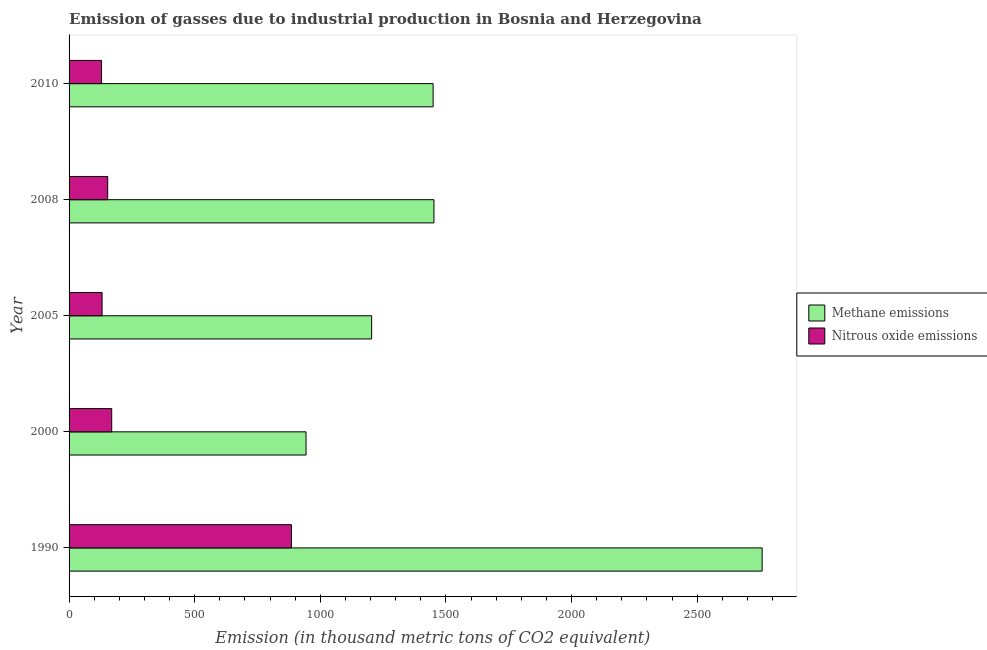How many different coloured bars are there?
Your response must be concise. 2. Are the number of bars per tick equal to the number of legend labels?
Provide a short and direct response. Yes. Are the number of bars on each tick of the Y-axis equal?
Give a very brief answer. Yes. In how many cases, is the number of bars for a given year not equal to the number of legend labels?
Provide a short and direct response. 0. What is the amount of methane emissions in 2008?
Offer a very short reply. 1452.3. Across all years, what is the maximum amount of methane emissions?
Provide a short and direct response. 2758.5. Across all years, what is the minimum amount of nitrous oxide emissions?
Your answer should be compact. 129.2. In which year was the amount of methane emissions maximum?
Your answer should be very brief. 1990. In which year was the amount of methane emissions minimum?
Give a very brief answer. 2000. What is the total amount of methane emissions in the graph?
Your answer should be very brief. 7807.3. What is the difference between the amount of methane emissions in 2005 and that in 2008?
Your answer should be compact. -248. What is the difference between the amount of nitrous oxide emissions in 2005 and the amount of methane emissions in 2008?
Keep it short and to the point. -1320.9. What is the average amount of methane emissions per year?
Make the answer very short. 1561.46. In the year 2008, what is the difference between the amount of methane emissions and amount of nitrous oxide emissions?
Ensure brevity in your answer.  1298.6. What is the ratio of the amount of nitrous oxide emissions in 2000 to that in 2005?
Your answer should be very brief. 1.29. Is the difference between the amount of methane emissions in 1990 and 2000 greater than the difference between the amount of nitrous oxide emissions in 1990 and 2000?
Make the answer very short. Yes. What is the difference between the highest and the second highest amount of methane emissions?
Your response must be concise. 1306.2. What is the difference between the highest and the lowest amount of nitrous oxide emissions?
Your answer should be very brief. 755.8. Is the sum of the amount of methane emissions in 1990 and 2010 greater than the maximum amount of nitrous oxide emissions across all years?
Your answer should be very brief. Yes. What does the 2nd bar from the top in 2008 represents?
Offer a very short reply. Methane emissions. What does the 2nd bar from the bottom in 2005 represents?
Ensure brevity in your answer.  Nitrous oxide emissions. How many bars are there?
Offer a very short reply. 10. Are all the bars in the graph horizontal?
Give a very brief answer. Yes. Does the graph contain any zero values?
Make the answer very short. No. Does the graph contain grids?
Make the answer very short. No. Where does the legend appear in the graph?
Offer a very short reply. Center right. How many legend labels are there?
Keep it short and to the point. 2. How are the legend labels stacked?
Keep it short and to the point. Vertical. What is the title of the graph?
Provide a short and direct response. Emission of gasses due to industrial production in Bosnia and Herzegovina. What is the label or title of the X-axis?
Offer a terse response. Emission (in thousand metric tons of CO2 equivalent). What is the label or title of the Y-axis?
Give a very brief answer. Year. What is the Emission (in thousand metric tons of CO2 equivalent) of Methane emissions in 1990?
Offer a terse response. 2758.5. What is the Emission (in thousand metric tons of CO2 equivalent) of Nitrous oxide emissions in 1990?
Offer a very short reply. 885. What is the Emission (in thousand metric tons of CO2 equivalent) in Methane emissions in 2000?
Give a very brief answer. 943.2. What is the Emission (in thousand metric tons of CO2 equivalent) of Nitrous oxide emissions in 2000?
Offer a very short reply. 169.7. What is the Emission (in thousand metric tons of CO2 equivalent) of Methane emissions in 2005?
Keep it short and to the point. 1204.3. What is the Emission (in thousand metric tons of CO2 equivalent) of Nitrous oxide emissions in 2005?
Make the answer very short. 131.4. What is the Emission (in thousand metric tons of CO2 equivalent) in Methane emissions in 2008?
Ensure brevity in your answer.  1452.3. What is the Emission (in thousand metric tons of CO2 equivalent) of Nitrous oxide emissions in 2008?
Offer a terse response. 153.7. What is the Emission (in thousand metric tons of CO2 equivalent) in Methane emissions in 2010?
Ensure brevity in your answer.  1449. What is the Emission (in thousand metric tons of CO2 equivalent) of Nitrous oxide emissions in 2010?
Your answer should be compact. 129.2. Across all years, what is the maximum Emission (in thousand metric tons of CO2 equivalent) of Methane emissions?
Provide a succinct answer. 2758.5. Across all years, what is the maximum Emission (in thousand metric tons of CO2 equivalent) of Nitrous oxide emissions?
Give a very brief answer. 885. Across all years, what is the minimum Emission (in thousand metric tons of CO2 equivalent) of Methane emissions?
Your answer should be compact. 943.2. Across all years, what is the minimum Emission (in thousand metric tons of CO2 equivalent) in Nitrous oxide emissions?
Your answer should be compact. 129.2. What is the total Emission (in thousand metric tons of CO2 equivalent) of Methane emissions in the graph?
Offer a terse response. 7807.3. What is the total Emission (in thousand metric tons of CO2 equivalent) in Nitrous oxide emissions in the graph?
Provide a short and direct response. 1469. What is the difference between the Emission (in thousand metric tons of CO2 equivalent) in Methane emissions in 1990 and that in 2000?
Provide a succinct answer. 1815.3. What is the difference between the Emission (in thousand metric tons of CO2 equivalent) in Nitrous oxide emissions in 1990 and that in 2000?
Keep it short and to the point. 715.3. What is the difference between the Emission (in thousand metric tons of CO2 equivalent) of Methane emissions in 1990 and that in 2005?
Offer a terse response. 1554.2. What is the difference between the Emission (in thousand metric tons of CO2 equivalent) of Nitrous oxide emissions in 1990 and that in 2005?
Keep it short and to the point. 753.6. What is the difference between the Emission (in thousand metric tons of CO2 equivalent) in Methane emissions in 1990 and that in 2008?
Offer a very short reply. 1306.2. What is the difference between the Emission (in thousand metric tons of CO2 equivalent) of Nitrous oxide emissions in 1990 and that in 2008?
Provide a succinct answer. 731.3. What is the difference between the Emission (in thousand metric tons of CO2 equivalent) of Methane emissions in 1990 and that in 2010?
Your response must be concise. 1309.5. What is the difference between the Emission (in thousand metric tons of CO2 equivalent) of Nitrous oxide emissions in 1990 and that in 2010?
Keep it short and to the point. 755.8. What is the difference between the Emission (in thousand metric tons of CO2 equivalent) of Methane emissions in 2000 and that in 2005?
Your answer should be very brief. -261.1. What is the difference between the Emission (in thousand metric tons of CO2 equivalent) of Nitrous oxide emissions in 2000 and that in 2005?
Give a very brief answer. 38.3. What is the difference between the Emission (in thousand metric tons of CO2 equivalent) in Methane emissions in 2000 and that in 2008?
Give a very brief answer. -509.1. What is the difference between the Emission (in thousand metric tons of CO2 equivalent) in Nitrous oxide emissions in 2000 and that in 2008?
Offer a very short reply. 16. What is the difference between the Emission (in thousand metric tons of CO2 equivalent) in Methane emissions in 2000 and that in 2010?
Offer a terse response. -505.8. What is the difference between the Emission (in thousand metric tons of CO2 equivalent) of Nitrous oxide emissions in 2000 and that in 2010?
Ensure brevity in your answer.  40.5. What is the difference between the Emission (in thousand metric tons of CO2 equivalent) of Methane emissions in 2005 and that in 2008?
Keep it short and to the point. -248. What is the difference between the Emission (in thousand metric tons of CO2 equivalent) of Nitrous oxide emissions in 2005 and that in 2008?
Make the answer very short. -22.3. What is the difference between the Emission (in thousand metric tons of CO2 equivalent) in Methane emissions in 2005 and that in 2010?
Give a very brief answer. -244.7. What is the difference between the Emission (in thousand metric tons of CO2 equivalent) of Nitrous oxide emissions in 2005 and that in 2010?
Offer a terse response. 2.2. What is the difference between the Emission (in thousand metric tons of CO2 equivalent) in Methane emissions in 1990 and the Emission (in thousand metric tons of CO2 equivalent) in Nitrous oxide emissions in 2000?
Offer a terse response. 2588.8. What is the difference between the Emission (in thousand metric tons of CO2 equivalent) in Methane emissions in 1990 and the Emission (in thousand metric tons of CO2 equivalent) in Nitrous oxide emissions in 2005?
Provide a short and direct response. 2627.1. What is the difference between the Emission (in thousand metric tons of CO2 equivalent) of Methane emissions in 1990 and the Emission (in thousand metric tons of CO2 equivalent) of Nitrous oxide emissions in 2008?
Your answer should be compact. 2604.8. What is the difference between the Emission (in thousand metric tons of CO2 equivalent) in Methane emissions in 1990 and the Emission (in thousand metric tons of CO2 equivalent) in Nitrous oxide emissions in 2010?
Your response must be concise. 2629.3. What is the difference between the Emission (in thousand metric tons of CO2 equivalent) in Methane emissions in 2000 and the Emission (in thousand metric tons of CO2 equivalent) in Nitrous oxide emissions in 2005?
Make the answer very short. 811.8. What is the difference between the Emission (in thousand metric tons of CO2 equivalent) of Methane emissions in 2000 and the Emission (in thousand metric tons of CO2 equivalent) of Nitrous oxide emissions in 2008?
Keep it short and to the point. 789.5. What is the difference between the Emission (in thousand metric tons of CO2 equivalent) in Methane emissions in 2000 and the Emission (in thousand metric tons of CO2 equivalent) in Nitrous oxide emissions in 2010?
Make the answer very short. 814. What is the difference between the Emission (in thousand metric tons of CO2 equivalent) in Methane emissions in 2005 and the Emission (in thousand metric tons of CO2 equivalent) in Nitrous oxide emissions in 2008?
Ensure brevity in your answer.  1050.6. What is the difference between the Emission (in thousand metric tons of CO2 equivalent) of Methane emissions in 2005 and the Emission (in thousand metric tons of CO2 equivalent) of Nitrous oxide emissions in 2010?
Ensure brevity in your answer.  1075.1. What is the difference between the Emission (in thousand metric tons of CO2 equivalent) of Methane emissions in 2008 and the Emission (in thousand metric tons of CO2 equivalent) of Nitrous oxide emissions in 2010?
Provide a short and direct response. 1323.1. What is the average Emission (in thousand metric tons of CO2 equivalent) in Methane emissions per year?
Provide a short and direct response. 1561.46. What is the average Emission (in thousand metric tons of CO2 equivalent) of Nitrous oxide emissions per year?
Provide a succinct answer. 293.8. In the year 1990, what is the difference between the Emission (in thousand metric tons of CO2 equivalent) of Methane emissions and Emission (in thousand metric tons of CO2 equivalent) of Nitrous oxide emissions?
Ensure brevity in your answer.  1873.5. In the year 2000, what is the difference between the Emission (in thousand metric tons of CO2 equivalent) in Methane emissions and Emission (in thousand metric tons of CO2 equivalent) in Nitrous oxide emissions?
Offer a terse response. 773.5. In the year 2005, what is the difference between the Emission (in thousand metric tons of CO2 equivalent) of Methane emissions and Emission (in thousand metric tons of CO2 equivalent) of Nitrous oxide emissions?
Your response must be concise. 1072.9. In the year 2008, what is the difference between the Emission (in thousand metric tons of CO2 equivalent) in Methane emissions and Emission (in thousand metric tons of CO2 equivalent) in Nitrous oxide emissions?
Provide a short and direct response. 1298.6. In the year 2010, what is the difference between the Emission (in thousand metric tons of CO2 equivalent) of Methane emissions and Emission (in thousand metric tons of CO2 equivalent) of Nitrous oxide emissions?
Keep it short and to the point. 1319.8. What is the ratio of the Emission (in thousand metric tons of CO2 equivalent) of Methane emissions in 1990 to that in 2000?
Provide a short and direct response. 2.92. What is the ratio of the Emission (in thousand metric tons of CO2 equivalent) in Nitrous oxide emissions in 1990 to that in 2000?
Your answer should be very brief. 5.22. What is the ratio of the Emission (in thousand metric tons of CO2 equivalent) in Methane emissions in 1990 to that in 2005?
Provide a succinct answer. 2.29. What is the ratio of the Emission (in thousand metric tons of CO2 equivalent) of Nitrous oxide emissions in 1990 to that in 2005?
Your response must be concise. 6.74. What is the ratio of the Emission (in thousand metric tons of CO2 equivalent) of Methane emissions in 1990 to that in 2008?
Give a very brief answer. 1.9. What is the ratio of the Emission (in thousand metric tons of CO2 equivalent) of Nitrous oxide emissions in 1990 to that in 2008?
Keep it short and to the point. 5.76. What is the ratio of the Emission (in thousand metric tons of CO2 equivalent) of Methane emissions in 1990 to that in 2010?
Your answer should be very brief. 1.9. What is the ratio of the Emission (in thousand metric tons of CO2 equivalent) of Nitrous oxide emissions in 1990 to that in 2010?
Your answer should be very brief. 6.85. What is the ratio of the Emission (in thousand metric tons of CO2 equivalent) in Methane emissions in 2000 to that in 2005?
Ensure brevity in your answer.  0.78. What is the ratio of the Emission (in thousand metric tons of CO2 equivalent) of Nitrous oxide emissions in 2000 to that in 2005?
Provide a succinct answer. 1.29. What is the ratio of the Emission (in thousand metric tons of CO2 equivalent) in Methane emissions in 2000 to that in 2008?
Keep it short and to the point. 0.65. What is the ratio of the Emission (in thousand metric tons of CO2 equivalent) in Nitrous oxide emissions in 2000 to that in 2008?
Your answer should be compact. 1.1. What is the ratio of the Emission (in thousand metric tons of CO2 equivalent) in Methane emissions in 2000 to that in 2010?
Offer a very short reply. 0.65. What is the ratio of the Emission (in thousand metric tons of CO2 equivalent) in Nitrous oxide emissions in 2000 to that in 2010?
Your answer should be compact. 1.31. What is the ratio of the Emission (in thousand metric tons of CO2 equivalent) of Methane emissions in 2005 to that in 2008?
Keep it short and to the point. 0.83. What is the ratio of the Emission (in thousand metric tons of CO2 equivalent) in Nitrous oxide emissions in 2005 to that in 2008?
Your answer should be compact. 0.85. What is the ratio of the Emission (in thousand metric tons of CO2 equivalent) of Methane emissions in 2005 to that in 2010?
Your response must be concise. 0.83. What is the ratio of the Emission (in thousand metric tons of CO2 equivalent) in Methane emissions in 2008 to that in 2010?
Provide a short and direct response. 1. What is the ratio of the Emission (in thousand metric tons of CO2 equivalent) in Nitrous oxide emissions in 2008 to that in 2010?
Provide a short and direct response. 1.19. What is the difference between the highest and the second highest Emission (in thousand metric tons of CO2 equivalent) in Methane emissions?
Provide a short and direct response. 1306.2. What is the difference between the highest and the second highest Emission (in thousand metric tons of CO2 equivalent) of Nitrous oxide emissions?
Ensure brevity in your answer.  715.3. What is the difference between the highest and the lowest Emission (in thousand metric tons of CO2 equivalent) of Methane emissions?
Your answer should be compact. 1815.3. What is the difference between the highest and the lowest Emission (in thousand metric tons of CO2 equivalent) in Nitrous oxide emissions?
Make the answer very short. 755.8. 